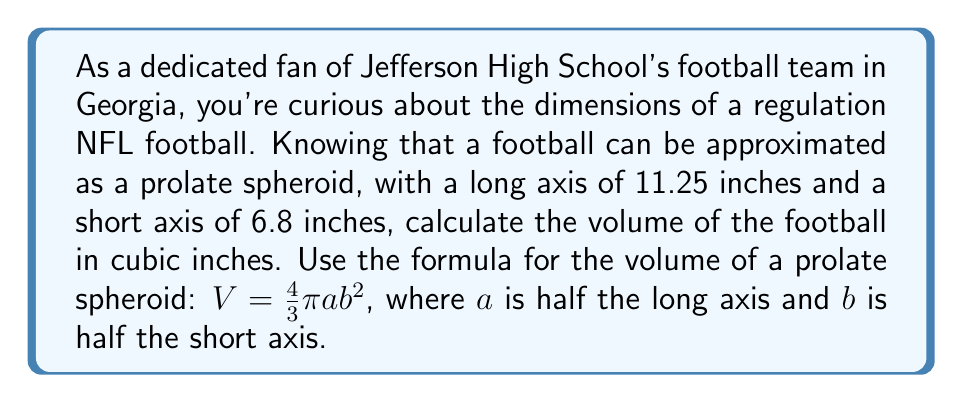Help me with this question. Let's approach this step-by-step:

1) First, we need to identify our values:
   - Long axis = 11.25 inches
   - Short axis = 6.8 inches

2) In the formula $V = \frac{4}{3}\pi ab^2$, we need:
   - $a$ = half of the long axis
   - $b$ = half of the short axis

3) Calculate $a$ and $b$:
   $a = \frac{11.25}{2} = 5.625$ inches
   $b = \frac{6.8}{2} = 3.4$ inches

4) Now, let's substitute these values into our formula:

   $$V = \frac{4}{3}\pi (5.625)(3.4)^2$$

5) Let's calculate step by step:
   $$V = \frac{4}{3}\pi (5.625)(11.56)$$
   $$V = \frac{4}{3}\pi (65.025)$$
   $$V = \frac{4}{3} (204.2785...)$$
   $$V = 272.3713...$$

6) Rounding to two decimal places:
   $$V \approx 272.37 \text{ cubic inches}$$
Answer: The volume of the football is approximately 272.37 cubic inches. 